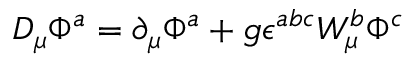Convert formula to latex. <formula><loc_0><loc_0><loc_500><loc_500>D _ { \mu } \Phi ^ { a } = \partial _ { \mu } \Phi ^ { a } + g \epsilon ^ { a b c } W _ { \mu } ^ { b } \Phi ^ { c }</formula> 